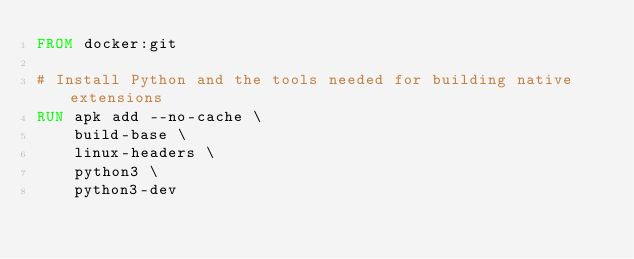<code> <loc_0><loc_0><loc_500><loc_500><_Dockerfile_>FROM docker:git

# Install Python and the tools needed for building native extensions
RUN apk add --no-cache \
	build-base \
	linux-headers \
	python3 \
	python3-dev
</code> 